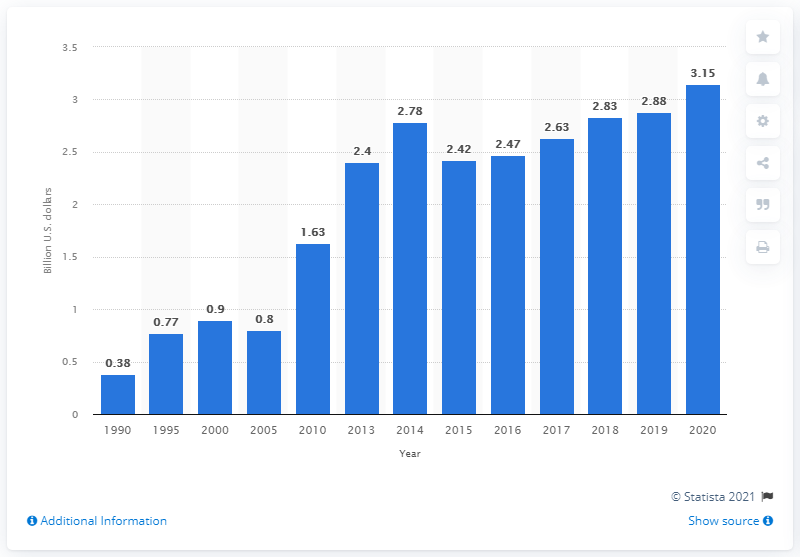Give some essential details in this illustration. In 2020, the value of U.S. agricultural exports to the Philippines was 3.15 billion dollars. 